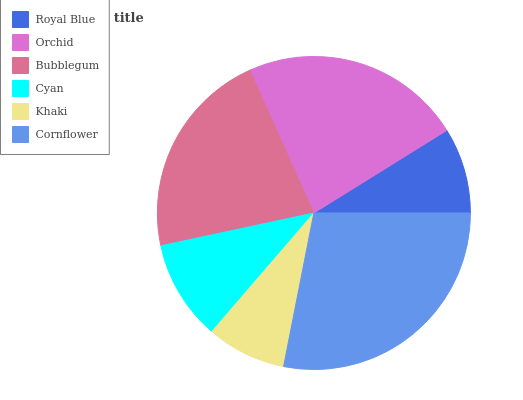Is Khaki the minimum?
Answer yes or no. Yes. Is Cornflower the maximum?
Answer yes or no. Yes. Is Orchid the minimum?
Answer yes or no. No. Is Orchid the maximum?
Answer yes or no. No. Is Orchid greater than Royal Blue?
Answer yes or no. Yes. Is Royal Blue less than Orchid?
Answer yes or no. Yes. Is Royal Blue greater than Orchid?
Answer yes or no. No. Is Orchid less than Royal Blue?
Answer yes or no. No. Is Bubblegum the high median?
Answer yes or no. Yes. Is Cyan the low median?
Answer yes or no. Yes. Is Khaki the high median?
Answer yes or no. No. Is Royal Blue the low median?
Answer yes or no. No. 